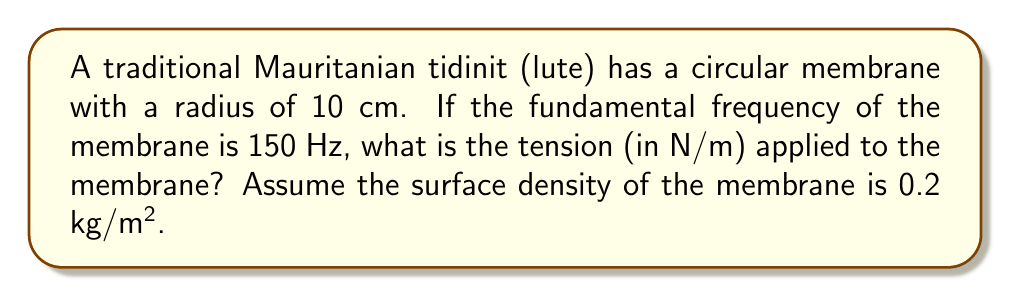Can you solve this math problem? To solve this problem, we'll use the equation for the fundamental frequency of a circular membrane:

$$ f = \frac{2.405}{2\pi r} \sqrt{\frac{T}{\rho}} $$

Where:
$f$ = fundamental frequency (Hz)
$r$ = radius of the membrane (m)
$T$ = tension (N/m)
$\rho$ = surface density (kg/m²)

Given:
$f = 150$ Hz
$r = 10$ cm $= 0.1$ m
$\rho = 0.2$ kg/m²

Step 1: Rearrange the equation to solve for T:
$$ T = \left(\frac{2\pi rf}{2.405}\right)^2 \rho $$

Step 2: Substitute the known values:
$$ T = \left(\frac{2\pi \cdot 0.1 \cdot 150}{2.405}\right)^2 \cdot 0.2 $$

Step 3: Calculate the result:
$$ T = (39.27)^2 \cdot 0.2 = 1542.53 \cdot 0.2 = 308.51 \text{ N/m} $$

Step 4: Round to two decimal places:
$$ T \approx 308.51 \text{ N/m} $$
Answer: 308.51 N/m 